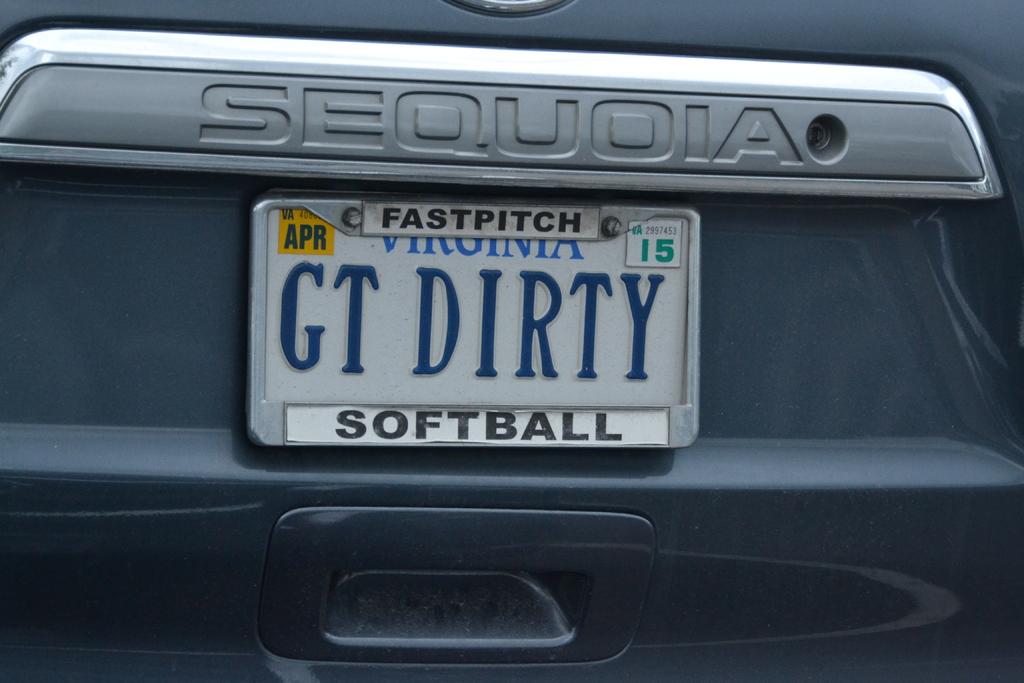What type of softball does this car owner prefer?
Make the answer very short. Fastpitch. What kind of car is pictured?
Your response must be concise. Sequoia. 